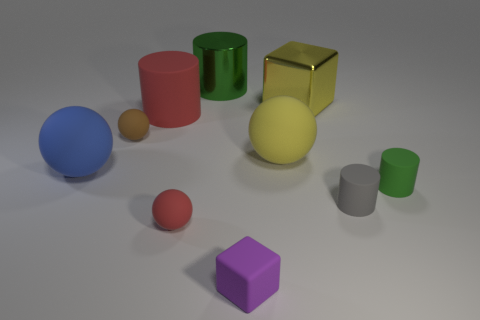Subtract 1 cylinders. How many cylinders are left? 3 Subtract all cylinders. How many objects are left? 6 Subtract 0 red blocks. How many objects are left? 10 Subtract all small brown rubber balls. Subtract all green metallic cylinders. How many objects are left? 8 Add 1 big green objects. How many big green objects are left? 2 Add 6 yellow matte balls. How many yellow matte balls exist? 7 